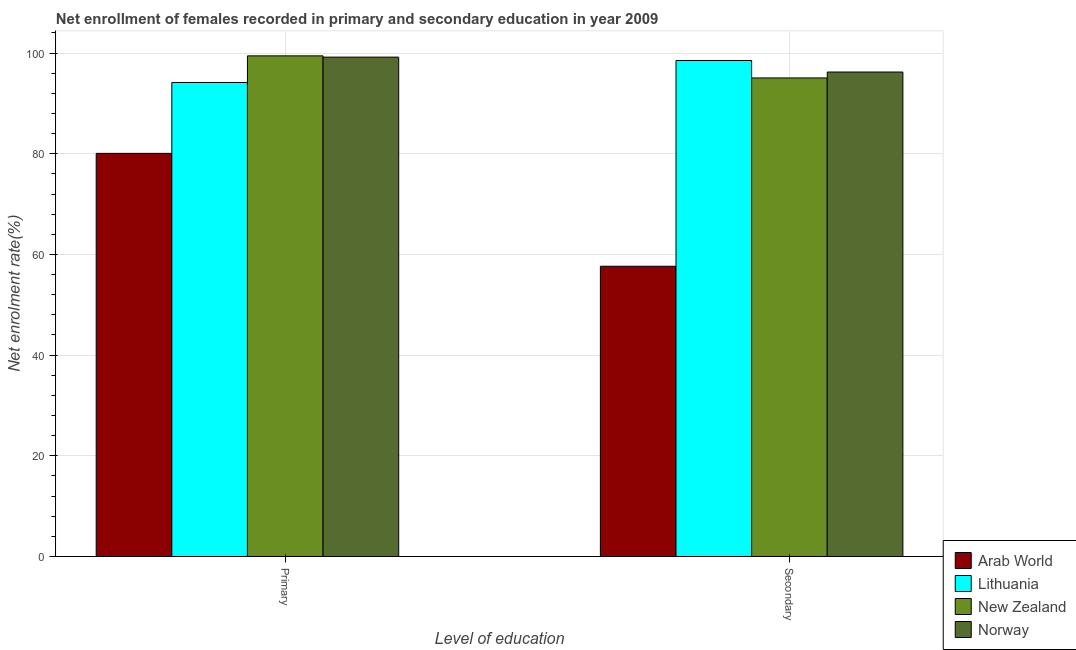How many groups of bars are there?
Keep it short and to the point. 2. Are the number of bars per tick equal to the number of legend labels?
Keep it short and to the point. Yes. Are the number of bars on each tick of the X-axis equal?
Make the answer very short. Yes. What is the label of the 1st group of bars from the left?
Ensure brevity in your answer.  Primary. What is the enrollment rate in primary education in Norway?
Your answer should be compact. 99.19. Across all countries, what is the maximum enrollment rate in secondary education?
Provide a short and direct response. 98.52. Across all countries, what is the minimum enrollment rate in primary education?
Give a very brief answer. 80.07. In which country was the enrollment rate in primary education maximum?
Make the answer very short. New Zealand. In which country was the enrollment rate in primary education minimum?
Your answer should be very brief. Arab World. What is the total enrollment rate in secondary education in the graph?
Provide a succinct answer. 347.45. What is the difference between the enrollment rate in secondary education in Lithuania and that in Norway?
Make the answer very short. 2.29. What is the difference between the enrollment rate in secondary education in Lithuania and the enrollment rate in primary education in Arab World?
Provide a succinct answer. 18.45. What is the average enrollment rate in primary education per country?
Keep it short and to the point. 93.21. What is the difference between the enrollment rate in primary education and enrollment rate in secondary education in New Zealand?
Keep it short and to the point. 4.39. In how many countries, is the enrollment rate in primary education greater than 100 %?
Keep it short and to the point. 0. What is the ratio of the enrollment rate in primary education in Lithuania to that in Arab World?
Make the answer very short. 1.18. Is the enrollment rate in secondary education in Arab World less than that in New Zealand?
Keep it short and to the point. Yes. In how many countries, is the enrollment rate in primary education greater than the average enrollment rate in primary education taken over all countries?
Provide a short and direct response. 3. What does the 3rd bar from the left in Primary represents?
Offer a very short reply. New Zealand. What does the 1st bar from the right in Primary represents?
Your response must be concise. Norway. What is the difference between two consecutive major ticks on the Y-axis?
Keep it short and to the point. 20. Does the graph contain any zero values?
Your answer should be very brief. No. Does the graph contain grids?
Provide a succinct answer. Yes. Where does the legend appear in the graph?
Your answer should be very brief. Bottom right. How many legend labels are there?
Offer a terse response. 4. What is the title of the graph?
Keep it short and to the point. Net enrollment of females recorded in primary and secondary education in year 2009. Does "Virgin Islands" appear as one of the legend labels in the graph?
Provide a succinct answer. No. What is the label or title of the X-axis?
Offer a terse response. Level of education. What is the label or title of the Y-axis?
Your response must be concise. Net enrolment rate(%). What is the Net enrolment rate(%) in Arab World in Primary?
Offer a very short reply. 80.07. What is the Net enrolment rate(%) in Lithuania in Primary?
Offer a very short reply. 94.15. What is the Net enrolment rate(%) of New Zealand in Primary?
Your response must be concise. 99.44. What is the Net enrolment rate(%) in Norway in Primary?
Make the answer very short. 99.19. What is the Net enrolment rate(%) in Arab World in Secondary?
Make the answer very short. 57.65. What is the Net enrolment rate(%) in Lithuania in Secondary?
Provide a short and direct response. 98.52. What is the Net enrolment rate(%) of New Zealand in Secondary?
Provide a short and direct response. 95.05. What is the Net enrolment rate(%) of Norway in Secondary?
Your answer should be very brief. 96.23. Across all Level of education, what is the maximum Net enrolment rate(%) of Arab World?
Ensure brevity in your answer.  80.07. Across all Level of education, what is the maximum Net enrolment rate(%) of Lithuania?
Offer a very short reply. 98.52. Across all Level of education, what is the maximum Net enrolment rate(%) of New Zealand?
Your answer should be compact. 99.44. Across all Level of education, what is the maximum Net enrolment rate(%) of Norway?
Offer a very short reply. 99.19. Across all Level of education, what is the minimum Net enrolment rate(%) in Arab World?
Give a very brief answer. 57.65. Across all Level of education, what is the minimum Net enrolment rate(%) in Lithuania?
Provide a succinct answer. 94.15. Across all Level of education, what is the minimum Net enrolment rate(%) in New Zealand?
Make the answer very short. 95.05. Across all Level of education, what is the minimum Net enrolment rate(%) of Norway?
Ensure brevity in your answer.  96.23. What is the total Net enrolment rate(%) of Arab World in the graph?
Ensure brevity in your answer.  137.72. What is the total Net enrolment rate(%) of Lithuania in the graph?
Provide a short and direct response. 192.67. What is the total Net enrolment rate(%) of New Zealand in the graph?
Keep it short and to the point. 194.49. What is the total Net enrolment rate(%) of Norway in the graph?
Your response must be concise. 195.41. What is the difference between the Net enrolment rate(%) in Arab World in Primary and that in Secondary?
Offer a very short reply. 22.42. What is the difference between the Net enrolment rate(%) of Lithuania in Primary and that in Secondary?
Your answer should be compact. -4.37. What is the difference between the Net enrolment rate(%) of New Zealand in Primary and that in Secondary?
Provide a short and direct response. 4.39. What is the difference between the Net enrolment rate(%) in Norway in Primary and that in Secondary?
Offer a terse response. 2.96. What is the difference between the Net enrolment rate(%) in Arab World in Primary and the Net enrolment rate(%) in Lithuania in Secondary?
Offer a terse response. -18.45. What is the difference between the Net enrolment rate(%) of Arab World in Primary and the Net enrolment rate(%) of New Zealand in Secondary?
Your answer should be compact. -14.98. What is the difference between the Net enrolment rate(%) of Arab World in Primary and the Net enrolment rate(%) of Norway in Secondary?
Offer a very short reply. -16.16. What is the difference between the Net enrolment rate(%) in Lithuania in Primary and the Net enrolment rate(%) in New Zealand in Secondary?
Provide a succinct answer. -0.9. What is the difference between the Net enrolment rate(%) in Lithuania in Primary and the Net enrolment rate(%) in Norway in Secondary?
Your answer should be compact. -2.08. What is the difference between the Net enrolment rate(%) of New Zealand in Primary and the Net enrolment rate(%) of Norway in Secondary?
Your answer should be very brief. 3.21. What is the average Net enrolment rate(%) of Arab World per Level of education?
Provide a succinct answer. 68.86. What is the average Net enrolment rate(%) in Lithuania per Level of education?
Offer a very short reply. 96.33. What is the average Net enrolment rate(%) in New Zealand per Level of education?
Your response must be concise. 97.25. What is the average Net enrolment rate(%) in Norway per Level of education?
Offer a terse response. 97.71. What is the difference between the Net enrolment rate(%) of Arab World and Net enrolment rate(%) of Lithuania in Primary?
Offer a very short reply. -14.08. What is the difference between the Net enrolment rate(%) in Arab World and Net enrolment rate(%) in New Zealand in Primary?
Offer a terse response. -19.37. What is the difference between the Net enrolment rate(%) in Arab World and Net enrolment rate(%) in Norway in Primary?
Keep it short and to the point. -19.12. What is the difference between the Net enrolment rate(%) of Lithuania and Net enrolment rate(%) of New Zealand in Primary?
Offer a terse response. -5.29. What is the difference between the Net enrolment rate(%) of Lithuania and Net enrolment rate(%) of Norway in Primary?
Offer a terse response. -5.04. What is the difference between the Net enrolment rate(%) of New Zealand and Net enrolment rate(%) of Norway in Primary?
Offer a very short reply. 0.25. What is the difference between the Net enrolment rate(%) of Arab World and Net enrolment rate(%) of Lithuania in Secondary?
Give a very brief answer. -40.87. What is the difference between the Net enrolment rate(%) of Arab World and Net enrolment rate(%) of New Zealand in Secondary?
Offer a terse response. -37.4. What is the difference between the Net enrolment rate(%) in Arab World and Net enrolment rate(%) in Norway in Secondary?
Offer a very short reply. -38.57. What is the difference between the Net enrolment rate(%) of Lithuania and Net enrolment rate(%) of New Zealand in Secondary?
Offer a terse response. 3.47. What is the difference between the Net enrolment rate(%) of Lithuania and Net enrolment rate(%) of Norway in Secondary?
Provide a short and direct response. 2.29. What is the difference between the Net enrolment rate(%) in New Zealand and Net enrolment rate(%) in Norway in Secondary?
Keep it short and to the point. -1.17. What is the ratio of the Net enrolment rate(%) in Arab World in Primary to that in Secondary?
Offer a very short reply. 1.39. What is the ratio of the Net enrolment rate(%) in Lithuania in Primary to that in Secondary?
Your answer should be very brief. 0.96. What is the ratio of the Net enrolment rate(%) in New Zealand in Primary to that in Secondary?
Offer a terse response. 1.05. What is the ratio of the Net enrolment rate(%) in Norway in Primary to that in Secondary?
Ensure brevity in your answer.  1.03. What is the difference between the highest and the second highest Net enrolment rate(%) of Arab World?
Offer a very short reply. 22.42. What is the difference between the highest and the second highest Net enrolment rate(%) in Lithuania?
Provide a short and direct response. 4.37. What is the difference between the highest and the second highest Net enrolment rate(%) of New Zealand?
Provide a succinct answer. 4.39. What is the difference between the highest and the second highest Net enrolment rate(%) in Norway?
Keep it short and to the point. 2.96. What is the difference between the highest and the lowest Net enrolment rate(%) in Arab World?
Your answer should be compact. 22.42. What is the difference between the highest and the lowest Net enrolment rate(%) in Lithuania?
Your response must be concise. 4.37. What is the difference between the highest and the lowest Net enrolment rate(%) in New Zealand?
Keep it short and to the point. 4.39. What is the difference between the highest and the lowest Net enrolment rate(%) in Norway?
Offer a very short reply. 2.96. 